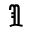Convert formula to latex. <formula><loc_0><loc_0><loc_500><loc_500>\Im</formula> 